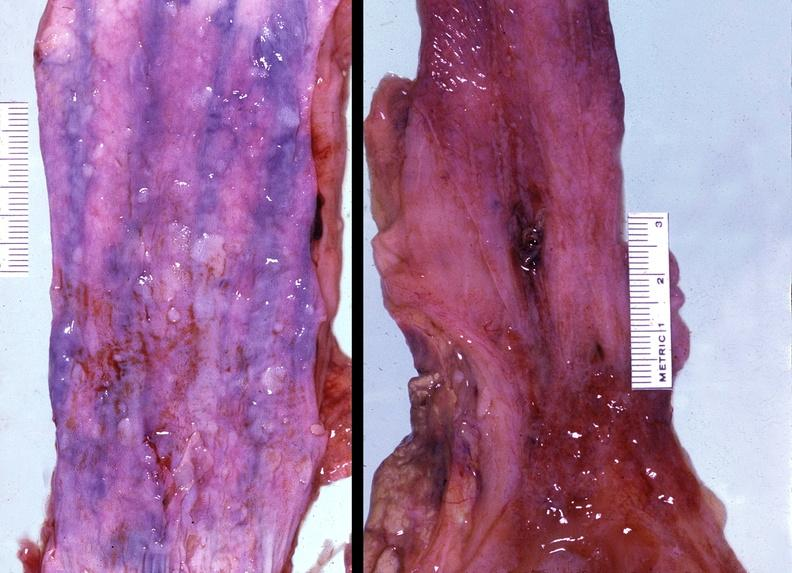where does this belong to?
Answer the question using a single word or phrase. Gastrointestinal system 